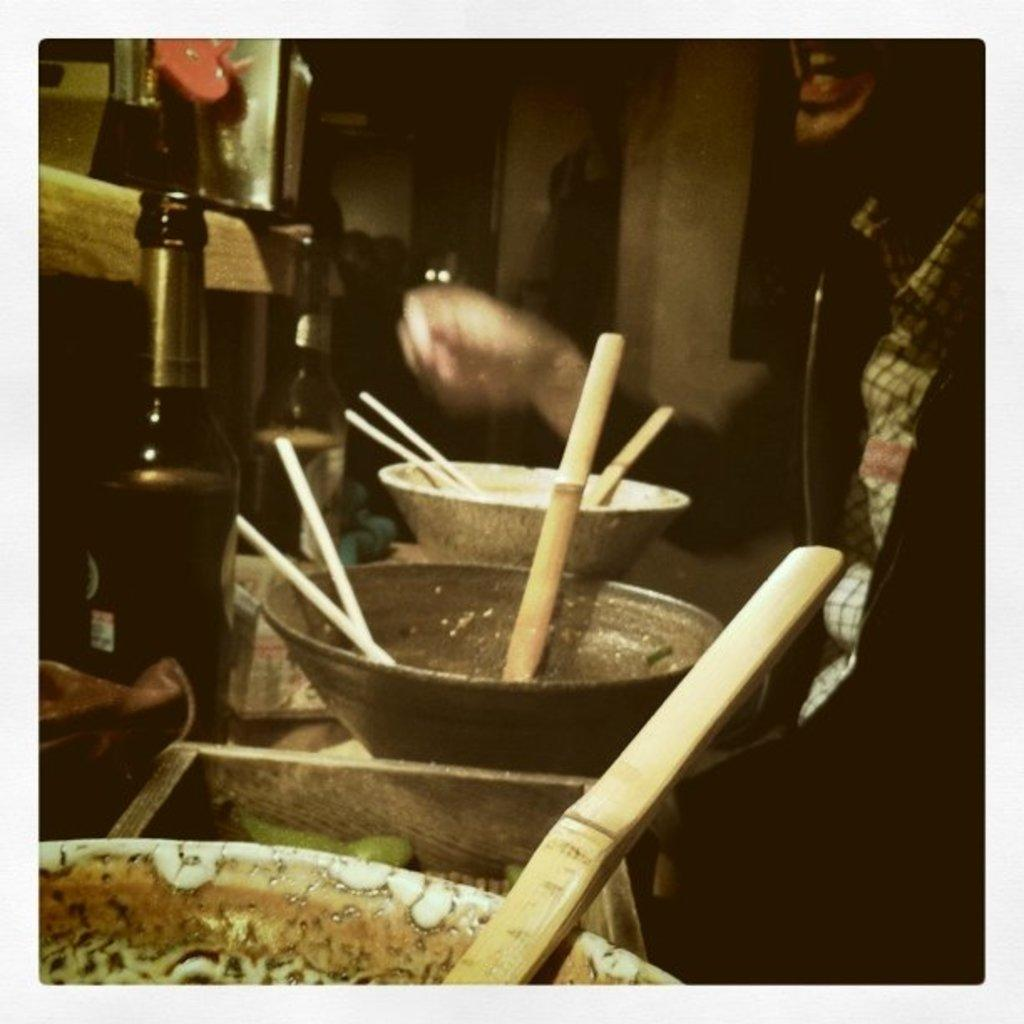What objects are on the table in the image? There are bowls, spoons, chopsticks, and bottles on the table in the image. What utensils are present for eating? Spoons and chopsticks are present for eating. Can you describe the person in the image? There is a person in the right corner of the image. What is the lighting condition in the image? The background of the image is dark and blurred. What type of bean is being cooked in the pot in the image? There is no pot or bean present in the image; it only features bowls, spoons, chopsticks, bottles, and a person. 